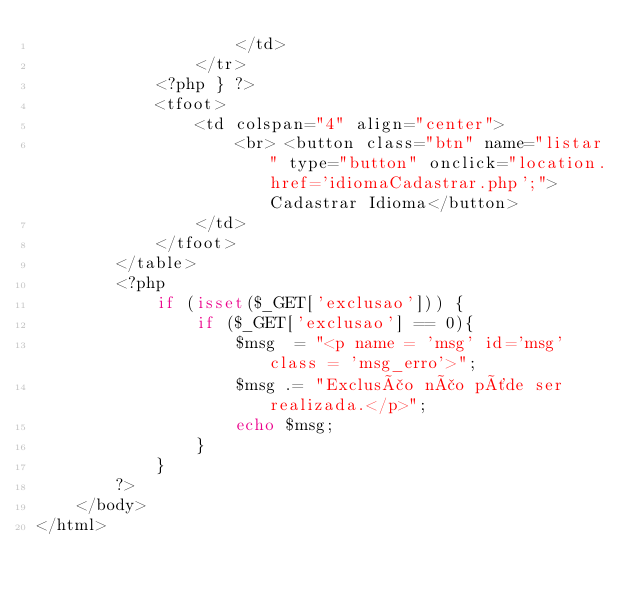Convert code to text. <code><loc_0><loc_0><loc_500><loc_500><_PHP_>                    </td>
                </tr>
            <?php } ?>
            <tfoot>
                <td colspan="4" align="center">
                    <br> <button class="btn" name="listar" type="button" onclick="location.href='idiomaCadastrar.php';">Cadastrar Idioma</button>
                </td>
            </tfoot>
        </table>
        <?php
            if (isset($_GET['exclusao'])) {
                if ($_GET['exclusao'] == 0){
                    $msg  = "<p name = 'msg' id='msg' class = 'msg_erro'>";
                    $msg .= "Exclusão não pôde ser realizada.</p>";                  
                    echo $msg;
                }
            }
        ?>       
    </body>
</html>
</code> 